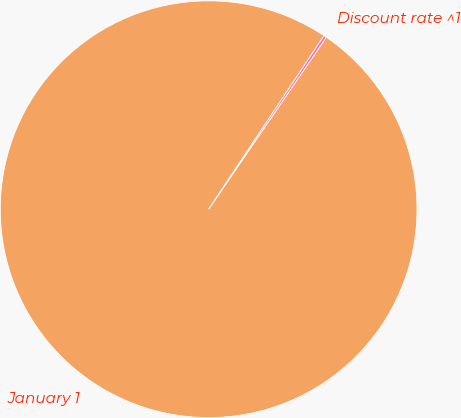Convert chart to OTSL. <chart><loc_0><loc_0><loc_500><loc_500><pie_chart><fcel>January 1<fcel>Discount rate ^1<nl><fcel>99.79%<fcel>0.21%<nl></chart> 